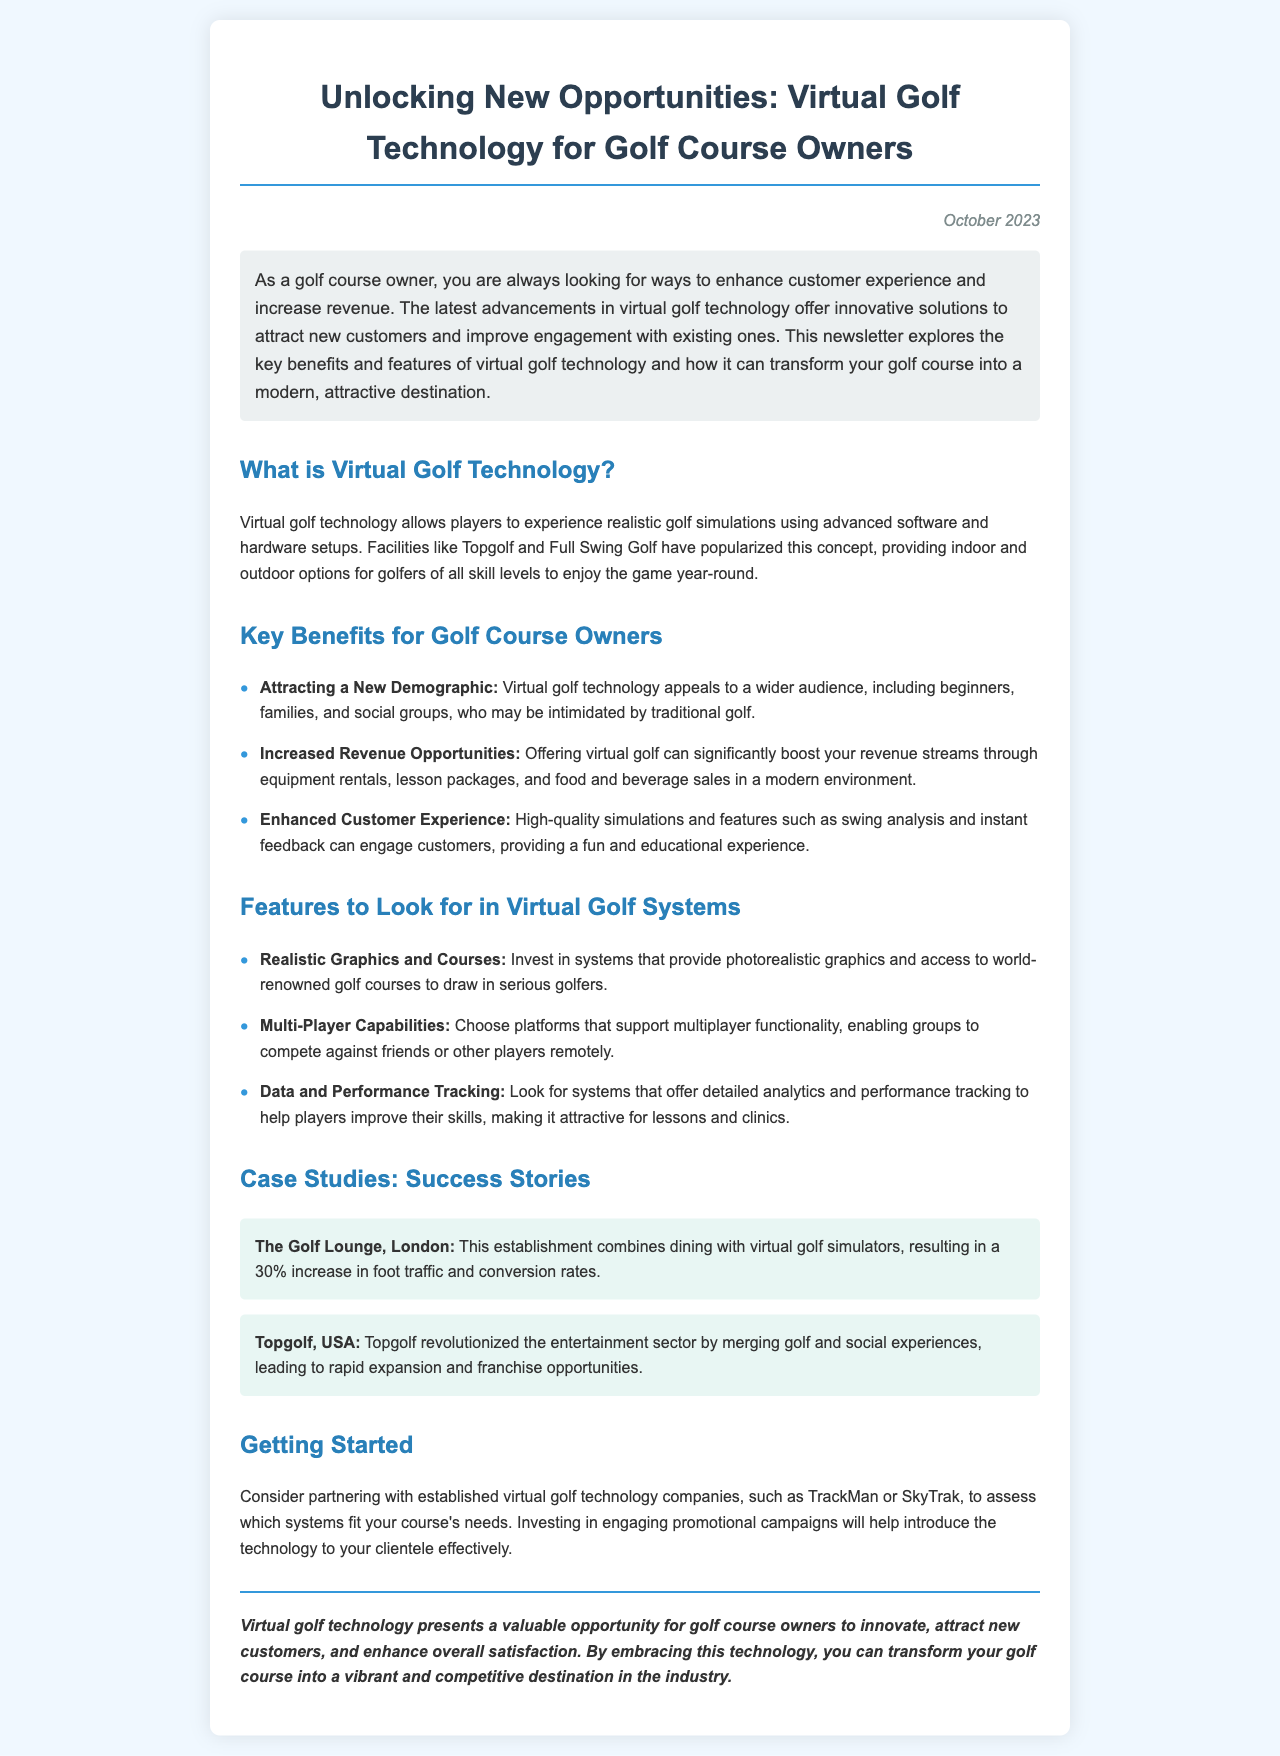What is the title of the newsletter? The title is located at the beginning of the document and introduces the main theme.
Answer: Unlocking New Opportunities: Virtual Golf Technology for Golf Course Owners What month and year was the newsletter published? The publication date appears at the top right of the document as part of the introductory information.
Answer: October 2023 What is one benefit of virtual golf technology for golf course owners? The document lists several benefits, including attracting new customers and enhancing the experience.
Answer: Attracting a New Demographic Which two companies are suggested for partnership in implementing virtual golf technology? The newsletter mentions specific companies that could be considered for partnership related to virtual golf systems.
Answer: TrackMan or SkyTrak How much did The Golf Lounge in London increase its foot traffic? A case study in the document provides a specific percentage increase attributed to implementing virtual golf.
Answer: 30% What feature should golf course owners look for regarding multiplayer capabilities? The document specifies a particular feature that allows groups to compete against friends or other players remotely.
Answer: Multi-Player Capabilities What type of analytics is mentioned as important for players? The document outlines features that can enhance the golfing experience by providing valuable insights to players.
Answer: Data and Performance Tracking Which establishment combined dining with virtual golf simulators? A case study highlights a specific establishment that merged two experiences to boost its success.
Answer: The Golf Lounge, London What is the background color of the document? The document's style section specifies the background color that creates a visually appealing layout.
Answer: #f0f8ff 